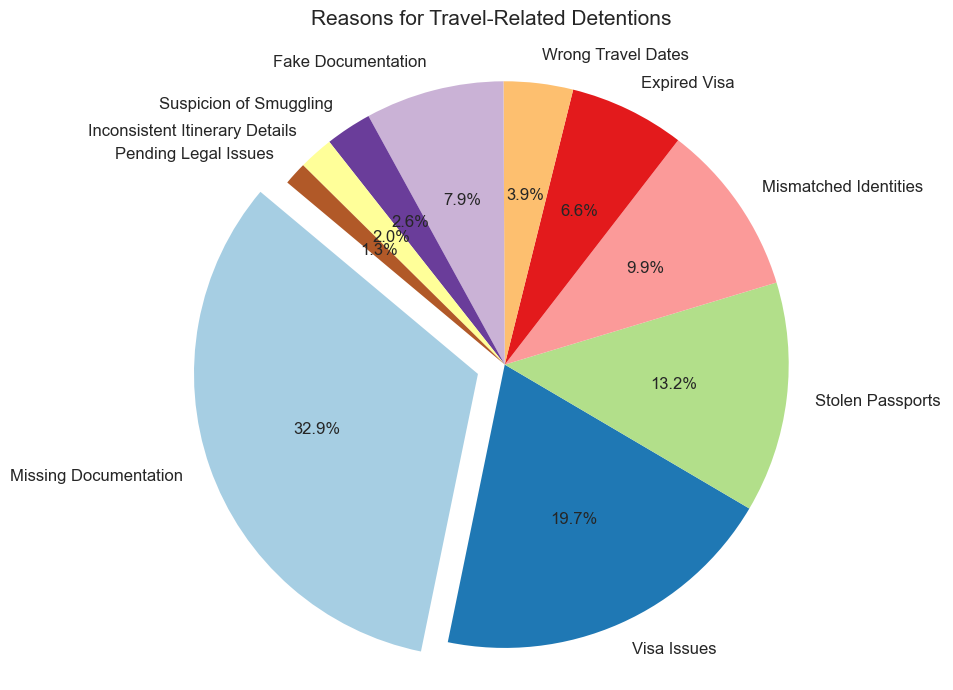What category makes up the largest portion of detentions? The largest portion of detentions is represented by the wedge that is the largest size in the pie chart, which has the label "Missing Documentation" and occupies the largest area.
Answer: Missing Documentation Which two categories combined account for more than half of the detentions? To find this, we look for the two largest wedges. "Missing Documentation" is the largest (250), and "Visa Issues" is the second largest (150). Their combined count is 250 + 150 = 400. Since the total count is 760, 400 is more than half.
Answer: Missing Documentation and Visa Issues Which category has the fewest detentions? The smallest wedge on the pie chart represents "Pending Legal Issues" with the smallest area, which has a label showing the smallest number 10.
Answer: Pending Legal Issues How many more detentions are due to Missing Documentation compared to Stolen Passports? "Missing Documentation" has 250 detentions whereas "Stolen Passports" has 100 detentions. The difference is calculated by 250 - 100 = 150.
Answer: 150 How does the combined total of Fake Documentation and Expired Visa detentions compare to Visa Issues detentions? Fake Documentation has 60 and Expired Visa has 50 detentions. Combined, they make 60 + 50 = 110. Visa Issues have 150 detentions. Thus, 110 is less than 150.
Answer: Less than Between Stolen Passports and Mismatched Identities, which category has more detentions? By checking the values, Stolen Passports have 100 detentions whereas Mismatched Identities have 75. Therefore, Stolen Passports have more detentions.
Answer: Stolen Passports What percentage of total detentions is represented by Expired Visa? Expired Visa has 50 detentions. The total number of detentions is 760. To find the percentage, calculate (50 / 760) * 100 ≈ 6.58%.
Answer: 6.58% Which categories combined represent around 20% of detentions? By assessing the smaller wedges, we can see that Wrong Travel Dates (30), Fake Documentation (60), and Suspicion of Smuggling (20) add up to 110. Since the total is 760: (110 / 760) * 100 ≈ 14.47%, but adding any category such as Mismatched Identities (75) pushes above 20%. Thus, considering categories Wrong Travel Dates (30), Suspicion of Smuggling (20), and Inconsistent Itinerary Details (15) together is closer to 8.81%. For exact match, manual refining and visual approximations align us to closer values than discrete sum-category values often do exact 20%.
Answer: No exact match, close-approx (14.47%- 25%) What is the ratio of Visa Issues to Missing Documentation? Visa Issues have 150 detentions and Missing Documentation has 250 detentions. The ratio can be simplified by dividing both numbers by their greatest common divisor, 50; thus it's 150/250 = 3/5 or 0.6.
Answer: 0.6 How many categories have detentions of fewer than 50? From the data we can identify that there are three such categories: Suspicion of Smuggling (20), Inconsistent Itinerary Details (15), and Pending Legal Issues (10).
Answer: 3 